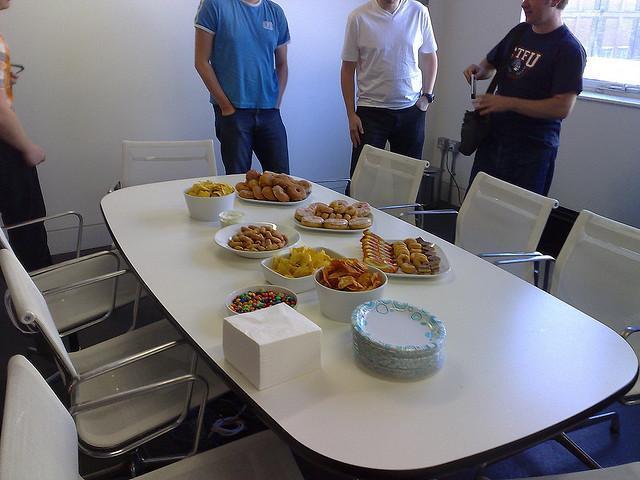How many seats are occupied?
Give a very brief answer. 0. How many bowls are filled with candy?
Give a very brief answer. 1. How many people are in the room?
Give a very brief answer. 4. How many chairs are there?
Give a very brief answer. 7. How many people can you see?
Give a very brief answer. 4. 